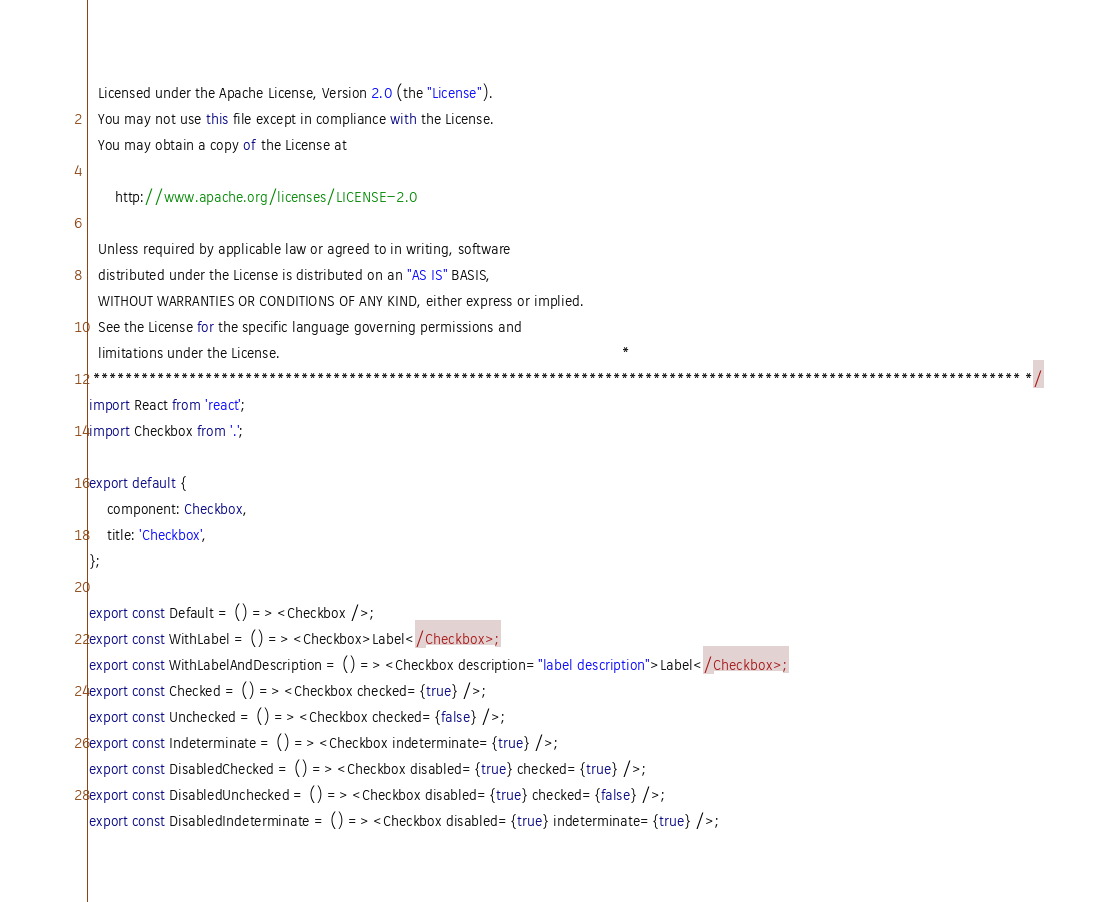<code> <loc_0><loc_0><loc_500><loc_500><_TypeScript_>  Licensed under the Apache License, Version 2.0 (the "License").
  You may not use this file except in compliance with the License.
  You may obtain a copy of the License at
  
      http://www.apache.org/licenses/LICENSE-2.0
  
  Unless required by applicable law or agreed to in writing, software
  distributed under the License is distributed on an "AS IS" BASIS,
  WITHOUT WARRANTIES OR CONDITIONS OF ANY KIND, either express or implied.
  See the License for the specific language governing permissions and
  limitations under the License.                                                                              *
 ******************************************************************************************************************** */
import React from 'react';
import Checkbox from '.';

export default {
    component: Checkbox,
    title: 'Checkbox',
};

export const Default = () => <Checkbox />;
export const WithLabel = () => <Checkbox>Label</Checkbox>;
export const WithLabelAndDescription = () => <Checkbox description="label description">Label</Checkbox>;
export const Checked = () => <Checkbox checked={true} />;
export const Unchecked = () => <Checkbox checked={false} />;
export const Indeterminate = () => <Checkbox indeterminate={true} />;
export const DisabledChecked = () => <Checkbox disabled={true} checked={true} />;
export const DisabledUnchecked = () => <Checkbox disabled={true} checked={false} />;
export const DisabledIndeterminate = () => <Checkbox disabled={true} indeterminate={true} />;
</code> 